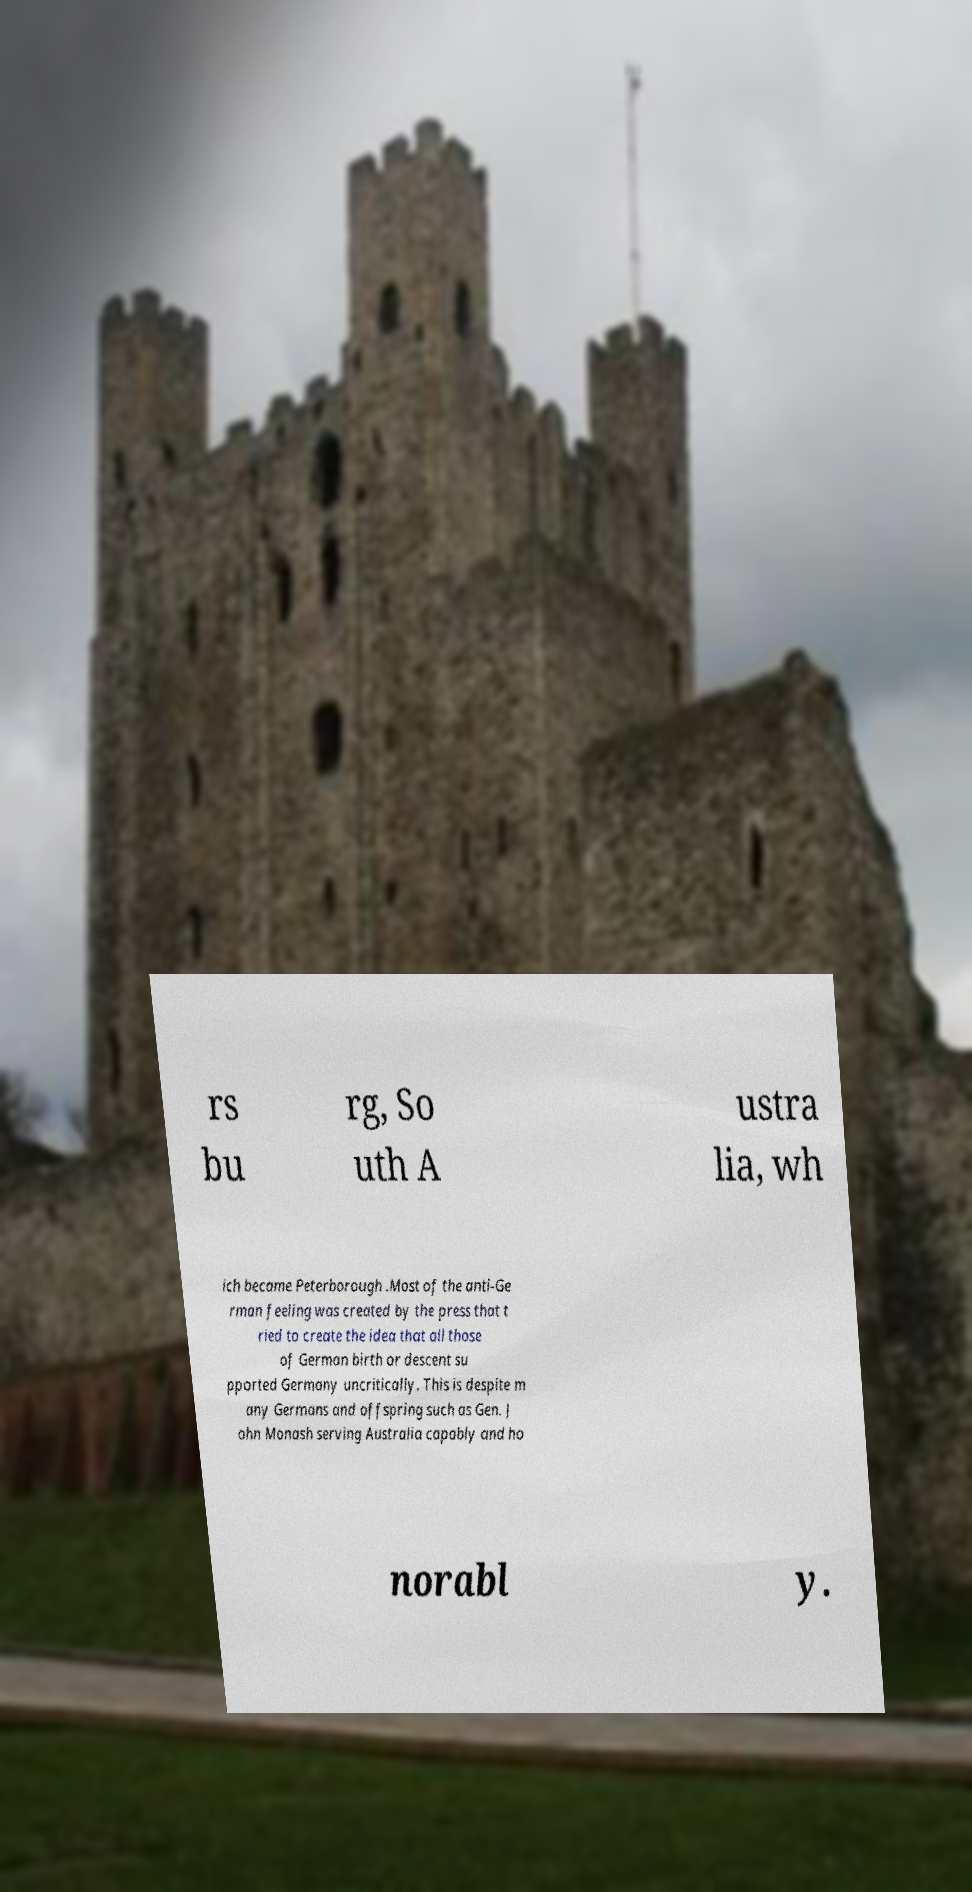Please identify and transcribe the text found in this image. rs bu rg, So uth A ustra lia, wh ich became Peterborough .Most of the anti-Ge rman feeling was created by the press that t ried to create the idea that all those of German birth or descent su pported Germany uncritically. This is despite m any Germans and offspring such as Gen. J ohn Monash serving Australia capably and ho norabl y. 